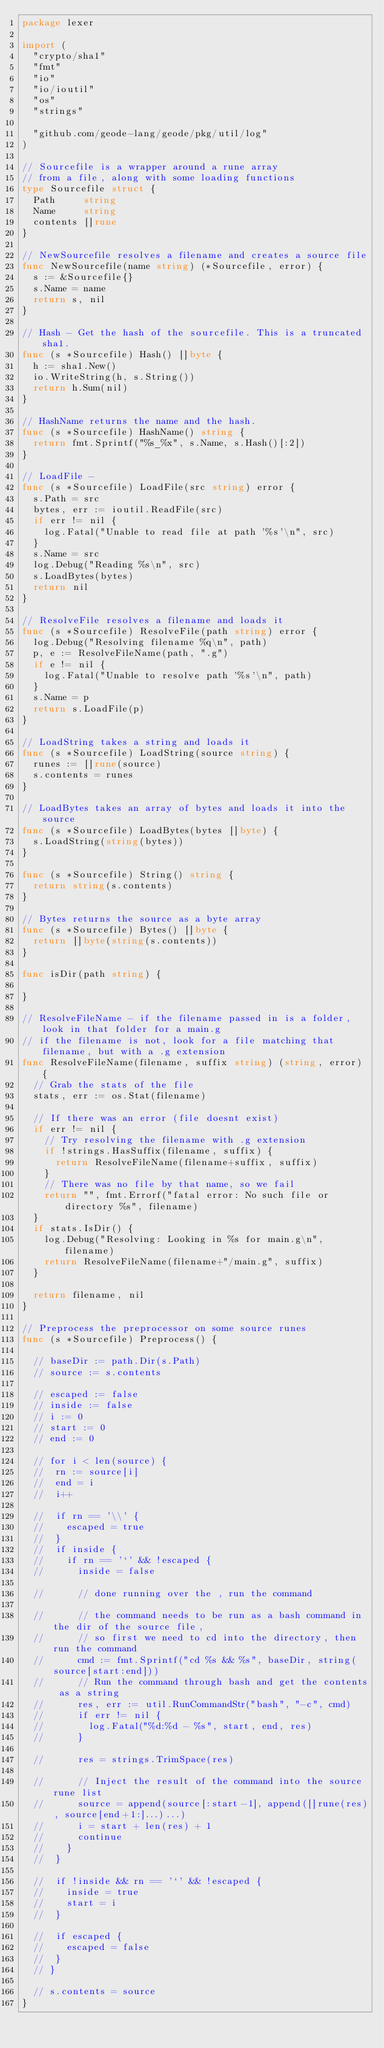<code> <loc_0><loc_0><loc_500><loc_500><_Go_>package lexer

import (
	"crypto/sha1"
	"fmt"
	"io"
	"io/ioutil"
	"os"
	"strings"

	"github.com/geode-lang/geode/pkg/util/log"
)

// Sourcefile is a wrapper around a rune array
// from a file, along with some loading functions
type Sourcefile struct {
	Path     string
	Name     string
	contents []rune
}

// NewSourcefile resolves a filename and creates a source file
func NewSourcefile(name string) (*Sourcefile, error) {
	s := &Sourcefile{}
	s.Name = name
	return s, nil
}

// Hash - Get the hash of the sourcefile. This is a truncated sha1.
func (s *Sourcefile) Hash() []byte {
	h := sha1.New()
	io.WriteString(h, s.String())
	return h.Sum(nil)
}

// HashName returns the name and the hash.
func (s *Sourcefile) HashName() string {
	return fmt.Sprintf("%s_%x", s.Name, s.Hash()[:2])
}

// LoadFile -
func (s *Sourcefile) LoadFile(src string) error {
	s.Path = src
	bytes, err := ioutil.ReadFile(src)
	if err != nil {
		log.Fatal("Unable to read file at path '%s'\n", src)
	}
	s.Name = src
	log.Debug("Reading %s\n", src)
	s.LoadBytes(bytes)
	return nil
}

// ResolveFile resolves a filename and loads it
func (s *Sourcefile) ResolveFile(path string) error {
	log.Debug("Resolving filename %q\n", path)
	p, e := ResolveFileName(path, ".g")
	if e != nil {
		log.Fatal("Unable to resolve path '%s'\n", path)
	}
	s.Name = p
	return s.LoadFile(p)
}

// LoadString takes a string and loads it
func (s *Sourcefile) LoadString(source string) {
	runes := []rune(source)
	s.contents = runes
}

// LoadBytes takes an array of bytes and loads it into the source
func (s *Sourcefile) LoadBytes(bytes []byte) {
	s.LoadString(string(bytes))
}

func (s *Sourcefile) String() string {
	return string(s.contents)
}

// Bytes returns the source as a byte array
func (s *Sourcefile) Bytes() []byte {
	return []byte(string(s.contents))
}

func isDir(path string) {

}

// ResolveFileName - if the filename passed in is a folder, look in that folder for a main.g
// if the filename is not, look for a file matching that filename, but with a .g extension
func ResolveFileName(filename, suffix string) (string, error) {
	// Grab the stats of the file
	stats, err := os.Stat(filename)

	// If there was an error (file doesnt exist)
	if err != nil {
		// Try resolving the filename with .g extension
		if !strings.HasSuffix(filename, suffix) {
			return ResolveFileName(filename+suffix, suffix)
		}
		// There was no file by that name, so we fail
		return "", fmt.Errorf("fatal error: No such file or directory %s", filename)
	}
	if stats.IsDir() {
		log.Debug("Resolving: Looking in %s for main.g\n", filename)
		return ResolveFileName(filename+"/main.g", suffix)
	}

	return filename, nil
}

// Preprocess the preprocessor on some source runes
func (s *Sourcefile) Preprocess() {

	// baseDir := path.Dir(s.Path)
	// source := s.contents

	// escaped := false
	// inside := false
	// i := 0
	// start := 0
	// end := 0

	// for i < len(source) {
	// 	rn := source[i]
	// 	end = i
	// 	i++

	// 	if rn == '\\' {
	// 		escaped = true
	// 	}
	// 	if inside {
	// 		if rn == '`' && !escaped {
	// 			inside = false

	// 			// done running over the , run the command

	// 			// the command needs to be run as a bash command in the dir of the source file,
	// 			// so first we need to cd into the directory, then run the command
	// 			cmd := fmt.Sprintf("cd %s && %s", baseDir, string(source[start:end]))
	// 			// Run the command through bash and get the contents as a string
	// 			res, err := util.RunCommandStr("bash", "-c", cmd)
	// 			if err != nil {
	// 				log.Fatal("%d:%d - %s", start, end, res)
	// 			}

	// 			res = strings.TrimSpace(res)

	// 			// Inject the result of the command into the source rune list
	// 			source = append(source[:start-1], append([]rune(res), source[end+1:]...)...)
	// 			i = start + len(res) + 1
	// 			continue
	// 		}
	// 	}

	// 	if !inside && rn == '`' && !escaped {
	// 		inside = true
	// 		start = i
	// 	}

	// 	if escaped {
	// 		escaped = false
	// 	}
	// }

	// s.contents = source
}
</code> 